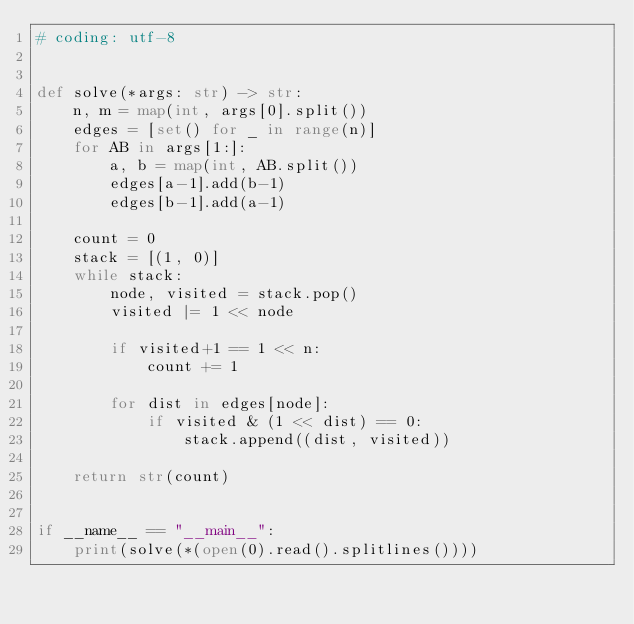Convert code to text. <code><loc_0><loc_0><loc_500><loc_500><_Python_># coding: utf-8


def solve(*args: str) -> str:
    n, m = map(int, args[0].split())
    edges = [set() for _ in range(n)]
    for AB in args[1:]:
        a, b = map(int, AB.split())
        edges[a-1].add(b-1)
        edges[b-1].add(a-1)

    count = 0
    stack = [(1, 0)]
    while stack:
        node, visited = stack.pop()
        visited |= 1 << node

        if visited+1 == 1 << n:
            count += 1

        for dist in edges[node]:
            if visited & (1 << dist) == 0:
                stack.append((dist, visited))

    return str(count)


if __name__ == "__main__":
    print(solve(*(open(0).read().splitlines())))
</code> 